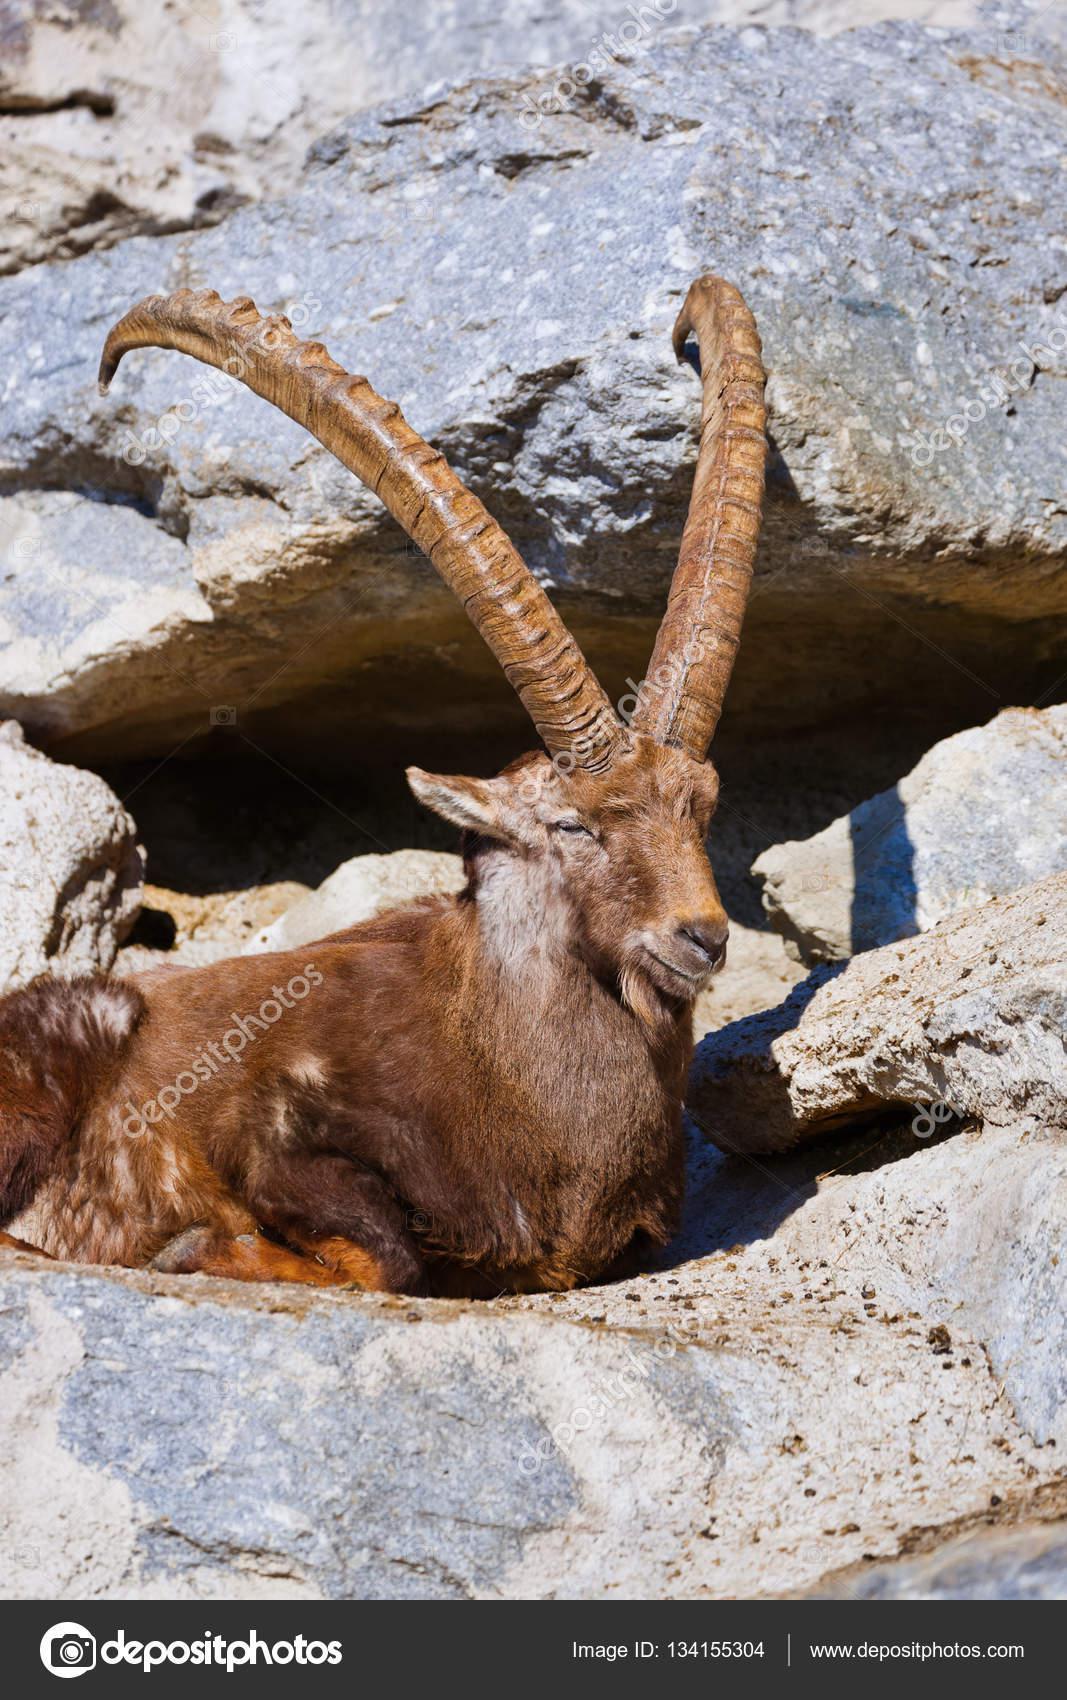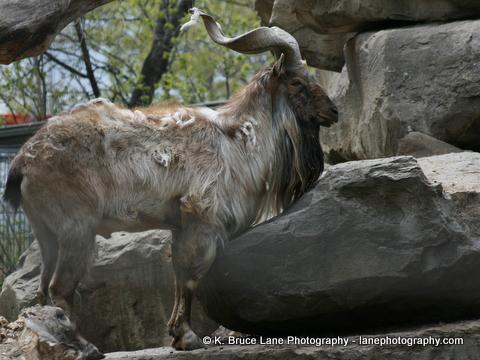The first image is the image on the left, the second image is the image on the right. Considering the images on both sides, is "The left and right image contains the same number of goats." valid? Answer yes or no. Yes. The first image is the image on the left, the second image is the image on the right. For the images shown, is this caption "The large ram is standing near small rams in one of the images." true? Answer yes or no. No. 